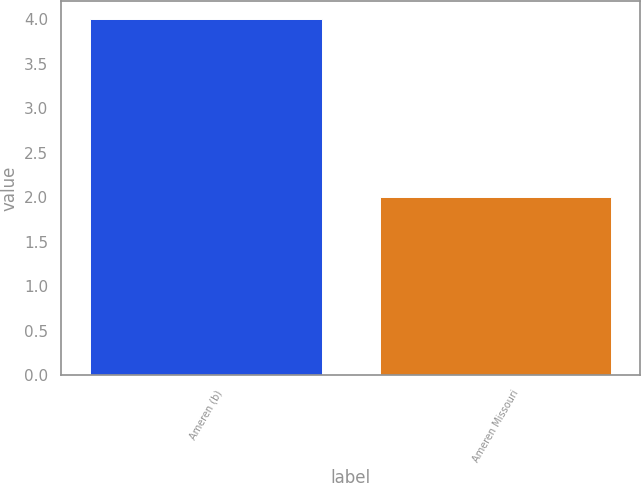Convert chart to OTSL. <chart><loc_0><loc_0><loc_500><loc_500><bar_chart><fcel>Ameren (b)<fcel>Ameren Missouri<nl><fcel>4<fcel>2<nl></chart> 